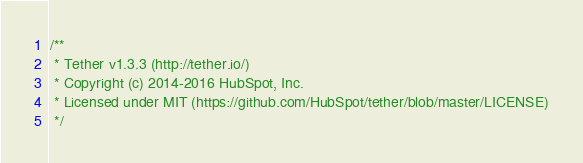Convert code to text. <code><loc_0><loc_0><loc_500><loc_500><_JavaScript_>/**
 * Tether v1.3.3 (http://tether.io/)
 * Copyright (c) 2014-2016 HubSpot, Inc.
 * Licensed under MIT (https://github.com/HubSpot/tether/blob/master/LICENSE)
 */</code> 